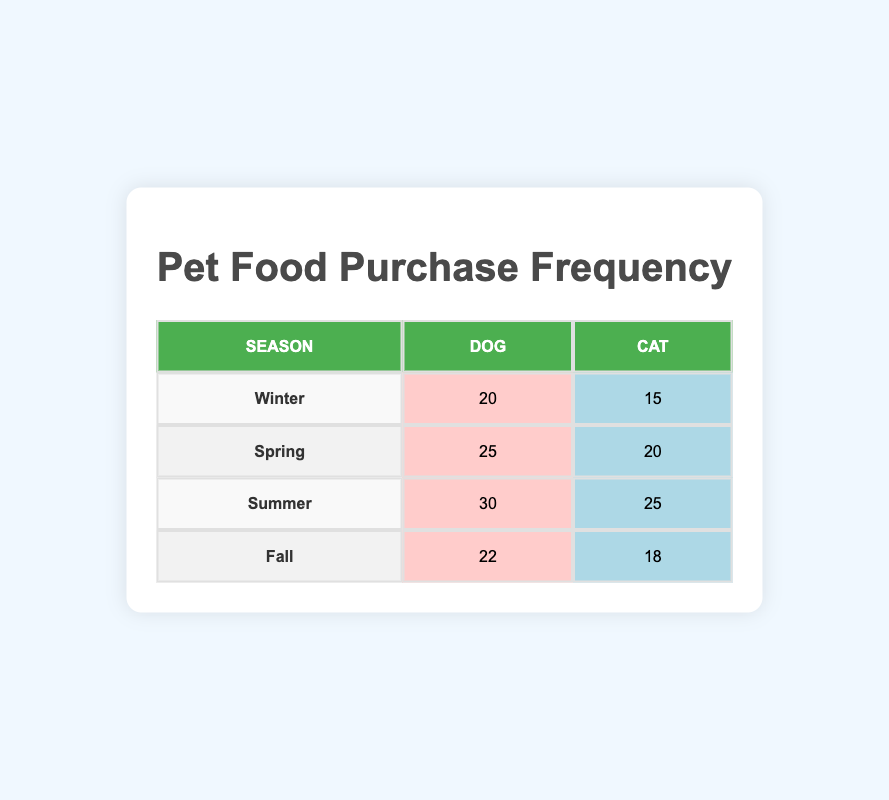What is the purchase frequency for dogs in summer? The table shows that in the summer season, the purchase frequency for dogs is listed in the respective column, which is 30.
Answer: 30 What is the purchase frequency for cats during winter? Referring to the winter row, the purchase frequency for cats is in the designated column, which indicates a value of 15.
Answer: 15 How many more frequent purchases do dog owners make compared to cat owners in fall? In the fall season, the purchase frequency for dogs is 22 and for cats is 18. The difference is calculated as follows: 22 - 18 = 4.
Answer: 4 What is the average purchase frequency for dogs across all seasons? The purchase frequencies for dogs are 20 (Winter), 25 (Spring), 30 (Summer), and 22 (Fall). Adding them gives 20 + 25 + 30 + 22 = 97. There are 4 seasons, so the average is 97 divided by 4, which equals 24.25.
Answer: 24.25 Did more cat owners purchase food in summer than in winter? In the summer, the purchase frequency for cats is 25, and during winter, it's 15. Since 25 is greater than 15, the answer is yes.
Answer: Yes Which season had the highest total purchase frequency for dog food? By reviewing the dog purchase frequencies: Winter (20), Spring (25), Summer (30), and Fall (22), the highest value here is 30, which occurs in summer.
Answer: Summer Is the total frequency of pet food purchases for dogs greater than that of cats in spring? In spring, dog's purchase frequency is 25, while for cats it is 20. Since 25 is greater than 20, the statement is true.
Answer: True What is the total purchase frequency for all seasons combined for cat owners? The table shows the following frequencies for cats: Winter (15), Spring (20), Summer (25), and Fall (18). Adding them together gives: 15 + 20 + 25 + 18 = 78.
Answer: 78 Which season had the lowest purchase frequency for cat food? Looking at the purchase frequencies for cats across all seasons: Winter (15), Spring (20), Summer (25), and Fall (18), the lowest value is 15 in the winter season.
Answer: Winter 